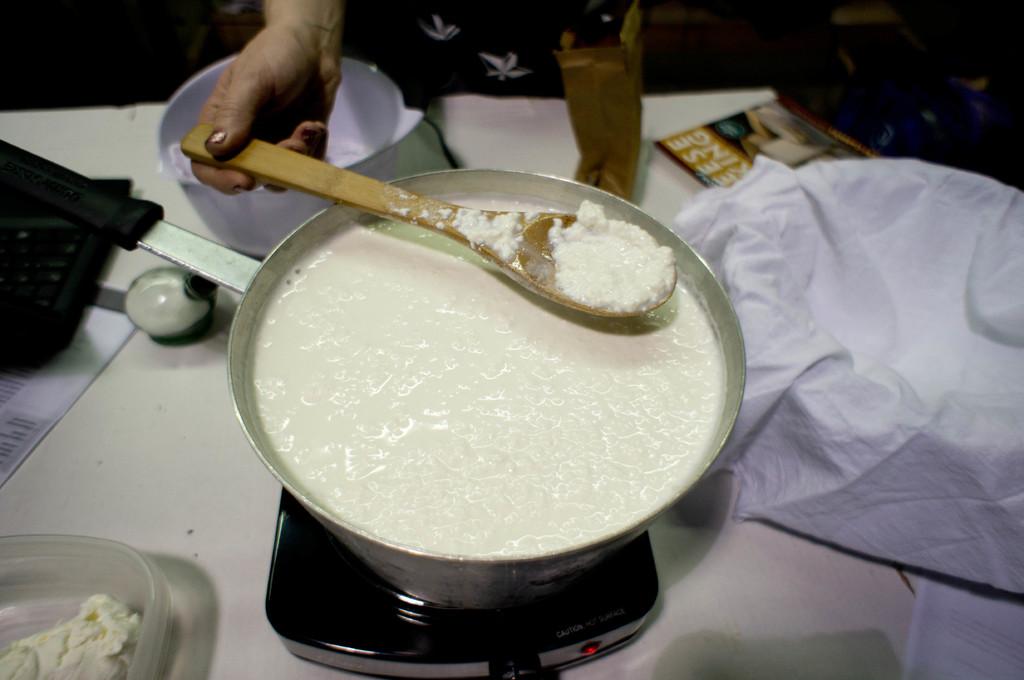What letters are on the book in the bacjground?
Make the answer very short. Eese king. 